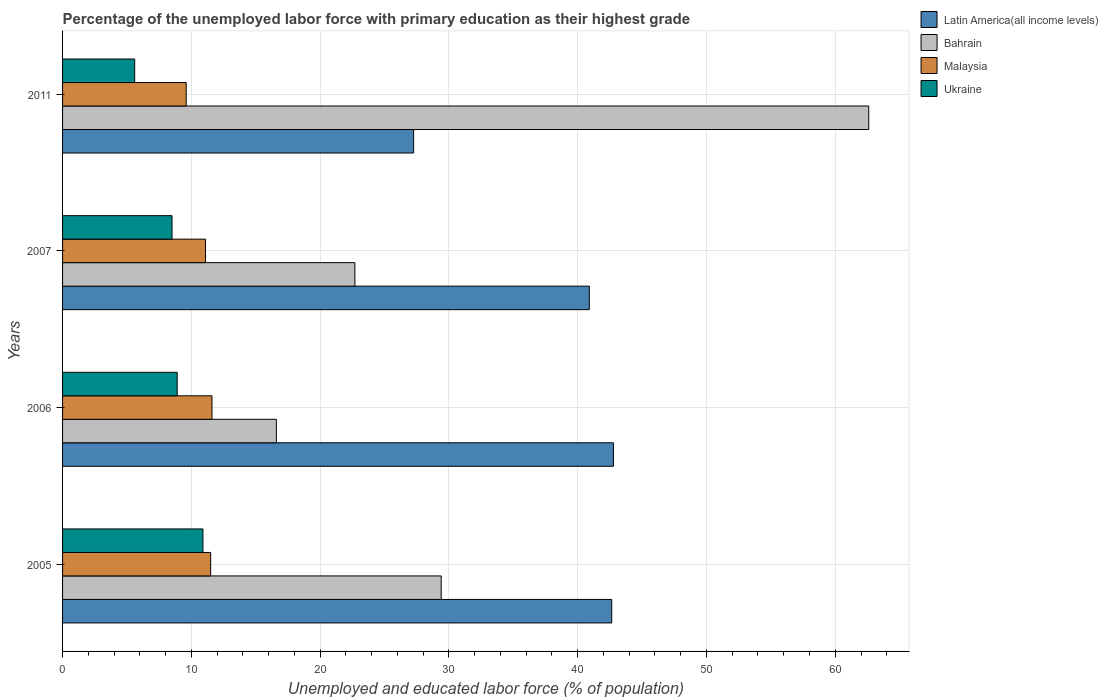How many different coloured bars are there?
Your answer should be compact. 4. How many bars are there on the 2nd tick from the bottom?
Provide a short and direct response. 4. What is the label of the 3rd group of bars from the top?
Keep it short and to the point. 2006. In how many cases, is the number of bars for a given year not equal to the number of legend labels?
Offer a very short reply. 0. What is the percentage of the unemployed labor force with primary education in Malaysia in 2005?
Provide a short and direct response. 11.5. Across all years, what is the maximum percentage of the unemployed labor force with primary education in Latin America(all income levels)?
Your answer should be compact. 42.78. Across all years, what is the minimum percentage of the unemployed labor force with primary education in Latin America(all income levels)?
Offer a terse response. 27.26. What is the total percentage of the unemployed labor force with primary education in Malaysia in the graph?
Your response must be concise. 43.8. What is the difference between the percentage of the unemployed labor force with primary education in Malaysia in 2006 and that in 2011?
Offer a terse response. 2. What is the difference between the percentage of the unemployed labor force with primary education in Latin America(all income levels) in 2006 and the percentage of the unemployed labor force with primary education in Ukraine in 2011?
Keep it short and to the point. 37.18. What is the average percentage of the unemployed labor force with primary education in Bahrain per year?
Your answer should be very brief. 32.82. In the year 2011, what is the difference between the percentage of the unemployed labor force with primary education in Malaysia and percentage of the unemployed labor force with primary education in Latin America(all income levels)?
Your answer should be very brief. -17.66. What is the ratio of the percentage of the unemployed labor force with primary education in Malaysia in 2005 to that in 2011?
Ensure brevity in your answer.  1.2. Is the percentage of the unemployed labor force with primary education in Ukraine in 2005 less than that in 2011?
Your response must be concise. No. What is the difference between the highest and the second highest percentage of the unemployed labor force with primary education in Bahrain?
Provide a short and direct response. 33.2. What is the difference between the highest and the lowest percentage of the unemployed labor force with primary education in Malaysia?
Offer a terse response. 2. What does the 1st bar from the top in 2007 represents?
Give a very brief answer. Ukraine. What does the 3rd bar from the bottom in 2011 represents?
Your answer should be very brief. Malaysia. What is the difference between two consecutive major ticks on the X-axis?
Your answer should be compact. 10. Are the values on the major ticks of X-axis written in scientific E-notation?
Offer a terse response. No. How many legend labels are there?
Your answer should be compact. 4. How are the legend labels stacked?
Offer a very short reply. Vertical. What is the title of the graph?
Offer a terse response. Percentage of the unemployed labor force with primary education as their highest grade. What is the label or title of the X-axis?
Provide a short and direct response. Unemployed and educated labor force (% of population). What is the label or title of the Y-axis?
Your answer should be very brief. Years. What is the Unemployed and educated labor force (% of population) in Latin America(all income levels) in 2005?
Provide a succinct answer. 42.64. What is the Unemployed and educated labor force (% of population) in Bahrain in 2005?
Your answer should be compact. 29.4. What is the Unemployed and educated labor force (% of population) of Malaysia in 2005?
Ensure brevity in your answer.  11.5. What is the Unemployed and educated labor force (% of population) of Ukraine in 2005?
Your response must be concise. 10.9. What is the Unemployed and educated labor force (% of population) in Latin America(all income levels) in 2006?
Your answer should be very brief. 42.78. What is the Unemployed and educated labor force (% of population) of Bahrain in 2006?
Keep it short and to the point. 16.6. What is the Unemployed and educated labor force (% of population) in Malaysia in 2006?
Make the answer very short. 11.6. What is the Unemployed and educated labor force (% of population) in Ukraine in 2006?
Your response must be concise. 8.9. What is the Unemployed and educated labor force (% of population) in Latin America(all income levels) in 2007?
Your answer should be very brief. 40.9. What is the Unemployed and educated labor force (% of population) in Bahrain in 2007?
Ensure brevity in your answer.  22.7. What is the Unemployed and educated labor force (% of population) of Malaysia in 2007?
Make the answer very short. 11.1. What is the Unemployed and educated labor force (% of population) of Ukraine in 2007?
Make the answer very short. 8.5. What is the Unemployed and educated labor force (% of population) in Latin America(all income levels) in 2011?
Your answer should be very brief. 27.26. What is the Unemployed and educated labor force (% of population) of Bahrain in 2011?
Provide a short and direct response. 62.6. What is the Unemployed and educated labor force (% of population) of Malaysia in 2011?
Provide a succinct answer. 9.6. What is the Unemployed and educated labor force (% of population) of Ukraine in 2011?
Offer a very short reply. 5.6. Across all years, what is the maximum Unemployed and educated labor force (% of population) in Latin America(all income levels)?
Your answer should be compact. 42.78. Across all years, what is the maximum Unemployed and educated labor force (% of population) of Bahrain?
Provide a short and direct response. 62.6. Across all years, what is the maximum Unemployed and educated labor force (% of population) in Malaysia?
Offer a very short reply. 11.6. Across all years, what is the maximum Unemployed and educated labor force (% of population) of Ukraine?
Keep it short and to the point. 10.9. Across all years, what is the minimum Unemployed and educated labor force (% of population) of Latin America(all income levels)?
Give a very brief answer. 27.26. Across all years, what is the minimum Unemployed and educated labor force (% of population) in Bahrain?
Your response must be concise. 16.6. Across all years, what is the minimum Unemployed and educated labor force (% of population) in Malaysia?
Your answer should be very brief. 9.6. Across all years, what is the minimum Unemployed and educated labor force (% of population) in Ukraine?
Your response must be concise. 5.6. What is the total Unemployed and educated labor force (% of population) in Latin America(all income levels) in the graph?
Offer a terse response. 153.58. What is the total Unemployed and educated labor force (% of population) of Bahrain in the graph?
Your answer should be compact. 131.3. What is the total Unemployed and educated labor force (% of population) of Malaysia in the graph?
Make the answer very short. 43.8. What is the total Unemployed and educated labor force (% of population) of Ukraine in the graph?
Your answer should be very brief. 33.9. What is the difference between the Unemployed and educated labor force (% of population) of Latin America(all income levels) in 2005 and that in 2006?
Provide a short and direct response. -0.13. What is the difference between the Unemployed and educated labor force (% of population) in Bahrain in 2005 and that in 2006?
Offer a very short reply. 12.8. What is the difference between the Unemployed and educated labor force (% of population) in Ukraine in 2005 and that in 2006?
Keep it short and to the point. 2. What is the difference between the Unemployed and educated labor force (% of population) of Latin America(all income levels) in 2005 and that in 2007?
Your response must be concise. 1.74. What is the difference between the Unemployed and educated labor force (% of population) in Bahrain in 2005 and that in 2007?
Make the answer very short. 6.7. What is the difference between the Unemployed and educated labor force (% of population) in Latin America(all income levels) in 2005 and that in 2011?
Keep it short and to the point. 15.38. What is the difference between the Unemployed and educated labor force (% of population) of Bahrain in 2005 and that in 2011?
Offer a terse response. -33.2. What is the difference between the Unemployed and educated labor force (% of population) of Latin America(all income levels) in 2006 and that in 2007?
Your response must be concise. 1.87. What is the difference between the Unemployed and educated labor force (% of population) in Latin America(all income levels) in 2006 and that in 2011?
Provide a short and direct response. 15.52. What is the difference between the Unemployed and educated labor force (% of population) of Bahrain in 2006 and that in 2011?
Provide a succinct answer. -46. What is the difference between the Unemployed and educated labor force (% of population) of Malaysia in 2006 and that in 2011?
Offer a very short reply. 2. What is the difference between the Unemployed and educated labor force (% of population) of Latin America(all income levels) in 2007 and that in 2011?
Keep it short and to the point. 13.65. What is the difference between the Unemployed and educated labor force (% of population) in Bahrain in 2007 and that in 2011?
Make the answer very short. -39.9. What is the difference between the Unemployed and educated labor force (% of population) in Ukraine in 2007 and that in 2011?
Keep it short and to the point. 2.9. What is the difference between the Unemployed and educated labor force (% of population) in Latin America(all income levels) in 2005 and the Unemployed and educated labor force (% of population) in Bahrain in 2006?
Provide a succinct answer. 26.04. What is the difference between the Unemployed and educated labor force (% of population) in Latin America(all income levels) in 2005 and the Unemployed and educated labor force (% of population) in Malaysia in 2006?
Your answer should be very brief. 31.04. What is the difference between the Unemployed and educated labor force (% of population) in Latin America(all income levels) in 2005 and the Unemployed and educated labor force (% of population) in Ukraine in 2006?
Your answer should be very brief. 33.74. What is the difference between the Unemployed and educated labor force (% of population) of Bahrain in 2005 and the Unemployed and educated labor force (% of population) of Malaysia in 2006?
Keep it short and to the point. 17.8. What is the difference between the Unemployed and educated labor force (% of population) of Latin America(all income levels) in 2005 and the Unemployed and educated labor force (% of population) of Bahrain in 2007?
Provide a succinct answer. 19.94. What is the difference between the Unemployed and educated labor force (% of population) in Latin America(all income levels) in 2005 and the Unemployed and educated labor force (% of population) in Malaysia in 2007?
Provide a succinct answer. 31.54. What is the difference between the Unemployed and educated labor force (% of population) of Latin America(all income levels) in 2005 and the Unemployed and educated labor force (% of population) of Ukraine in 2007?
Offer a very short reply. 34.14. What is the difference between the Unemployed and educated labor force (% of population) of Bahrain in 2005 and the Unemployed and educated labor force (% of population) of Malaysia in 2007?
Your answer should be very brief. 18.3. What is the difference between the Unemployed and educated labor force (% of population) in Bahrain in 2005 and the Unemployed and educated labor force (% of population) in Ukraine in 2007?
Your answer should be compact. 20.9. What is the difference between the Unemployed and educated labor force (% of population) in Latin America(all income levels) in 2005 and the Unemployed and educated labor force (% of population) in Bahrain in 2011?
Give a very brief answer. -19.96. What is the difference between the Unemployed and educated labor force (% of population) of Latin America(all income levels) in 2005 and the Unemployed and educated labor force (% of population) of Malaysia in 2011?
Your response must be concise. 33.04. What is the difference between the Unemployed and educated labor force (% of population) of Latin America(all income levels) in 2005 and the Unemployed and educated labor force (% of population) of Ukraine in 2011?
Give a very brief answer. 37.04. What is the difference between the Unemployed and educated labor force (% of population) in Bahrain in 2005 and the Unemployed and educated labor force (% of population) in Malaysia in 2011?
Give a very brief answer. 19.8. What is the difference between the Unemployed and educated labor force (% of population) of Bahrain in 2005 and the Unemployed and educated labor force (% of population) of Ukraine in 2011?
Keep it short and to the point. 23.8. What is the difference between the Unemployed and educated labor force (% of population) of Malaysia in 2005 and the Unemployed and educated labor force (% of population) of Ukraine in 2011?
Give a very brief answer. 5.9. What is the difference between the Unemployed and educated labor force (% of population) in Latin America(all income levels) in 2006 and the Unemployed and educated labor force (% of population) in Bahrain in 2007?
Offer a very short reply. 20.08. What is the difference between the Unemployed and educated labor force (% of population) in Latin America(all income levels) in 2006 and the Unemployed and educated labor force (% of population) in Malaysia in 2007?
Provide a short and direct response. 31.68. What is the difference between the Unemployed and educated labor force (% of population) in Latin America(all income levels) in 2006 and the Unemployed and educated labor force (% of population) in Ukraine in 2007?
Ensure brevity in your answer.  34.28. What is the difference between the Unemployed and educated labor force (% of population) of Malaysia in 2006 and the Unemployed and educated labor force (% of population) of Ukraine in 2007?
Keep it short and to the point. 3.1. What is the difference between the Unemployed and educated labor force (% of population) of Latin America(all income levels) in 2006 and the Unemployed and educated labor force (% of population) of Bahrain in 2011?
Offer a terse response. -19.82. What is the difference between the Unemployed and educated labor force (% of population) in Latin America(all income levels) in 2006 and the Unemployed and educated labor force (% of population) in Malaysia in 2011?
Provide a succinct answer. 33.18. What is the difference between the Unemployed and educated labor force (% of population) of Latin America(all income levels) in 2006 and the Unemployed and educated labor force (% of population) of Ukraine in 2011?
Your answer should be compact. 37.18. What is the difference between the Unemployed and educated labor force (% of population) of Bahrain in 2006 and the Unemployed and educated labor force (% of population) of Malaysia in 2011?
Ensure brevity in your answer.  7. What is the difference between the Unemployed and educated labor force (% of population) in Latin America(all income levels) in 2007 and the Unemployed and educated labor force (% of population) in Bahrain in 2011?
Make the answer very short. -21.7. What is the difference between the Unemployed and educated labor force (% of population) in Latin America(all income levels) in 2007 and the Unemployed and educated labor force (% of population) in Malaysia in 2011?
Give a very brief answer. 31.3. What is the difference between the Unemployed and educated labor force (% of population) of Latin America(all income levels) in 2007 and the Unemployed and educated labor force (% of population) of Ukraine in 2011?
Provide a succinct answer. 35.3. What is the difference between the Unemployed and educated labor force (% of population) of Bahrain in 2007 and the Unemployed and educated labor force (% of population) of Malaysia in 2011?
Ensure brevity in your answer.  13.1. What is the difference between the Unemployed and educated labor force (% of population) in Bahrain in 2007 and the Unemployed and educated labor force (% of population) in Ukraine in 2011?
Offer a very short reply. 17.1. What is the difference between the Unemployed and educated labor force (% of population) of Malaysia in 2007 and the Unemployed and educated labor force (% of population) of Ukraine in 2011?
Offer a very short reply. 5.5. What is the average Unemployed and educated labor force (% of population) of Latin America(all income levels) per year?
Keep it short and to the point. 38.4. What is the average Unemployed and educated labor force (% of population) of Bahrain per year?
Provide a succinct answer. 32.83. What is the average Unemployed and educated labor force (% of population) of Malaysia per year?
Your response must be concise. 10.95. What is the average Unemployed and educated labor force (% of population) of Ukraine per year?
Offer a terse response. 8.47. In the year 2005, what is the difference between the Unemployed and educated labor force (% of population) of Latin America(all income levels) and Unemployed and educated labor force (% of population) of Bahrain?
Your response must be concise. 13.24. In the year 2005, what is the difference between the Unemployed and educated labor force (% of population) of Latin America(all income levels) and Unemployed and educated labor force (% of population) of Malaysia?
Make the answer very short. 31.14. In the year 2005, what is the difference between the Unemployed and educated labor force (% of population) in Latin America(all income levels) and Unemployed and educated labor force (% of population) in Ukraine?
Give a very brief answer. 31.74. In the year 2006, what is the difference between the Unemployed and educated labor force (% of population) of Latin America(all income levels) and Unemployed and educated labor force (% of population) of Bahrain?
Ensure brevity in your answer.  26.18. In the year 2006, what is the difference between the Unemployed and educated labor force (% of population) in Latin America(all income levels) and Unemployed and educated labor force (% of population) in Malaysia?
Your response must be concise. 31.18. In the year 2006, what is the difference between the Unemployed and educated labor force (% of population) in Latin America(all income levels) and Unemployed and educated labor force (% of population) in Ukraine?
Ensure brevity in your answer.  33.88. In the year 2006, what is the difference between the Unemployed and educated labor force (% of population) in Bahrain and Unemployed and educated labor force (% of population) in Malaysia?
Your answer should be compact. 5. In the year 2007, what is the difference between the Unemployed and educated labor force (% of population) of Latin America(all income levels) and Unemployed and educated labor force (% of population) of Bahrain?
Your answer should be compact. 18.2. In the year 2007, what is the difference between the Unemployed and educated labor force (% of population) in Latin America(all income levels) and Unemployed and educated labor force (% of population) in Malaysia?
Your response must be concise. 29.8. In the year 2007, what is the difference between the Unemployed and educated labor force (% of population) in Latin America(all income levels) and Unemployed and educated labor force (% of population) in Ukraine?
Provide a short and direct response. 32.4. In the year 2007, what is the difference between the Unemployed and educated labor force (% of population) in Bahrain and Unemployed and educated labor force (% of population) in Malaysia?
Keep it short and to the point. 11.6. In the year 2007, what is the difference between the Unemployed and educated labor force (% of population) of Malaysia and Unemployed and educated labor force (% of population) of Ukraine?
Provide a short and direct response. 2.6. In the year 2011, what is the difference between the Unemployed and educated labor force (% of population) of Latin America(all income levels) and Unemployed and educated labor force (% of population) of Bahrain?
Offer a terse response. -35.34. In the year 2011, what is the difference between the Unemployed and educated labor force (% of population) of Latin America(all income levels) and Unemployed and educated labor force (% of population) of Malaysia?
Provide a succinct answer. 17.66. In the year 2011, what is the difference between the Unemployed and educated labor force (% of population) of Latin America(all income levels) and Unemployed and educated labor force (% of population) of Ukraine?
Provide a succinct answer. 21.66. In the year 2011, what is the difference between the Unemployed and educated labor force (% of population) in Bahrain and Unemployed and educated labor force (% of population) in Malaysia?
Ensure brevity in your answer.  53. In the year 2011, what is the difference between the Unemployed and educated labor force (% of population) of Bahrain and Unemployed and educated labor force (% of population) of Ukraine?
Keep it short and to the point. 57. What is the ratio of the Unemployed and educated labor force (% of population) in Latin America(all income levels) in 2005 to that in 2006?
Your answer should be compact. 1. What is the ratio of the Unemployed and educated labor force (% of population) of Bahrain in 2005 to that in 2006?
Ensure brevity in your answer.  1.77. What is the ratio of the Unemployed and educated labor force (% of population) of Ukraine in 2005 to that in 2006?
Ensure brevity in your answer.  1.22. What is the ratio of the Unemployed and educated labor force (% of population) in Latin America(all income levels) in 2005 to that in 2007?
Make the answer very short. 1.04. What is the ratio of the Unemployed and educated labor force (% of population) of Bahrain in 2005 to that in 2007?
Keep it short and to the point. 1.3. What is the ratio of the Unemployed and educated labor force (% of population) in Malaysia in 2005 to that in 2007?
Your response must be concise. 1.04. What is the ratio of the Unemployed and educated labor force (% of population) in Ukraine in 2005 to that in 2007?
Provide a succinct answer. 1.28. What is the ratio of the Unemployed and educated labor force (% of population) in Latin America(all income levels) in 2005 to that in 2011?
Provide a succinct answer. 1.56. What is the ratio of the Unemployed and educated labor force (% of population) in Bahrain in 2005 to that in 2011?
Your answer should be compact. 0.47. What is the ratio of the Unemployed and educated labor force (% of population) of Malaysia in 2005 to that in 2011?
Offer a terse response. 1.2. What is the ratio of the Unemployed and educated labor force (% of population) in Ukraine in 2005 to that in 2011?
Provide a succinct answer. 1.95. What is the ratio of the Unemployed and educated labor force (% of population) in Latin America(all income levels) in 2006 to that in 2007?
Keep it short and to the point. 1.05. What is the ratio of the Unemployed and educated labor force (% of population) of Bahrain in 2006 to that in 2007?
Provide a short and direct response. 0.73. What is the ratio of the Unemployed and educated labor force (% of population) in Malaysia in 2006 to that in 2007?
Give a very brief answer. 1.04. What is the ratio of the Unemployed and educated labor force (% of population) of Ukraine in 2006 to that in 2007?
Keep it short and to the point. 1.05. What is the ratio of the Unemployed and educated labor force (% of population) of Latin America(all income levels) in 2006 to that in 2011?
Provide a short and direct response. 1.57. What is the ratio of the Unemployed and educated labor force (% of population) in Bahrain in 2006 to that in 2011?
Ensure brevity in your answer.  0.27. What is the ratio of the Unemployed and educated labor force (% of population) in Malaysia in 2006 to that in 2011?
Offer a very short reply. 1.21. What is the ratio of the Unemployed and educated labor force (% of population) in Ukraine in 2006 to that in 2011?
Give a very brief answer. 1.59. What is the ratio of the Unemployed and educated labor force (% of population) in Latin America(all income levels) in 2007 to that in 2011?
Your response must be concise. 1.5. What is the ratio of the Unemployed and educated labor force (% of population) in Bahrain in 2007 to that in 2011?
Keep it short and to the point. 0.36. What is the ratio of the Unemployed and educated labor force (% of population) in Malaysia in 2007 to that in 2011?
Provide a short and direct response. 1.16. What is the ratio of the Unemployed and educated labor force (% of population) of Ukraine in 2007 to that in 2011?
Offer a terse response. 1.52. What is the difference between the highest and the second highest Unemployed and educated labor force (% of population) of Latin America(all income levels)?
Offer a terse response. 0.13. What is the difference between the highest and the second highest Unemployed and educated labor force (% of population) of Bahrain?
Keep it short and to the point. 33.2. What is the difference between the highest and the second highest Unemployed and educated labor force (% of population) of Ukraine?
Ensure brevity in your answer.  2. What is the difference between the highest and the lowest Unemployed and educated labor force (% of population) of Latin America(all income levels)?
Offer a terse response. 15.52. What is the difference between the highest and the lowest Unemployed and educated labor force (% of population) of Malaysia?
Offer a very short reply. 2. 